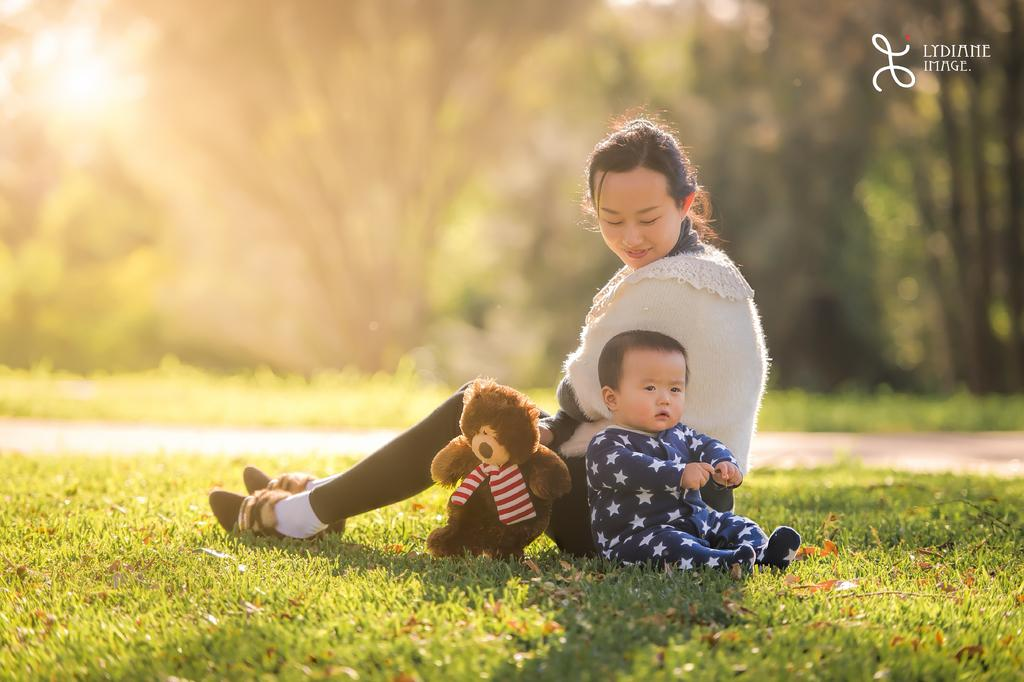Who is the main subject in the image? There is a woman in the image. What is the woman wearing? The woman is wearing a shrug. Where is the woman sitting? The woman is sitting on grass land. What else can be seen in the image besides the woman? There is a baby and a teddy bear in the image. What is visible in the background of the image? Trees are present in the background of the image. What can be seen on the left side of the image? The sun is visible on the left side of the image. How many legs does the teddy bear have in the image? The number of legs a teddy bear has cannot be determined from the image, as teddy bears are typically depicted with four legs, but the image may not show all of them. 